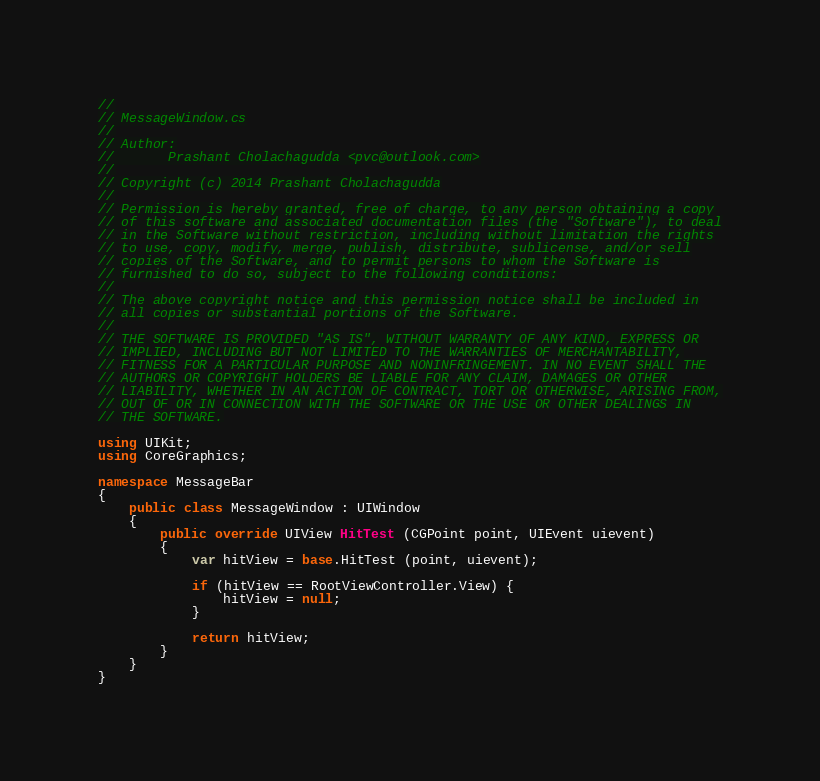<code> <loc_0><loc_0><loc_500><loc_500><_C#_>//
// MessageWindow.cs
//
// Author:
//       Prashant Cholachagudda <pvc@outlook.com>
//
// Copyright (c) 2014 Prashant Cholachagudda
//
// Permission is hereby granted, free of charge, to any person obtaining a copy
// of this software and associated documentation files (the "Software"), to deal
// in the Software without restriction, including without limitation the rights
// to use, copy, modify, merge, publish, distribute, sublicense, and/or sell
// copies of the Software, and to permit persons to whom the Software is
// furnished to do so, subject to the following conditions:
//
// The above copyright notice and this permission notice shall be included in
// all copies or substantial portions of the Software.
//
// THE SOFTWARE IS PROVIDED "AS IS", WITHOUT WARRANTY OF ANY KIND, EXPRESS OR
// IMPLIED, INCLUDING BUT NOT LIMITED TO THE WARRANTIES OF MERCHANTABILITY,
// FITNESS FOR A PARTICULAR PURPOSE AND NONINFRINGEMENT. IN NO EVENT SHALL THE
// AUTHORS OR COPYRIGHT HOLDERS BE LIABLE FOR ANY CLAIM, DAMAGES OR OTHER
// LIABILITY, WHETHER IN AN ACTION OF CONTRACT, TORT OR OTHERWISE, ARISING FROM,
// OUT OF OR IN CONNECTION WITH THE SOFTWARE OR THE USE OR OTHER DEALINGS IN
// THE SOFTWARE.

using UIKit;
using CoreGraphics;

namespace MessageBar
{
	public class MessageWindow : UIWindow
	{
		public override UIView HitTest (CGPoint point, UIEvent uievent)
		{
			var hitView = base.HitTest (point, uievent);

			if (hitView == RootViewController.View) {
				hitView = null;
			}

			return hitView;
		}
	}
}

</code> 